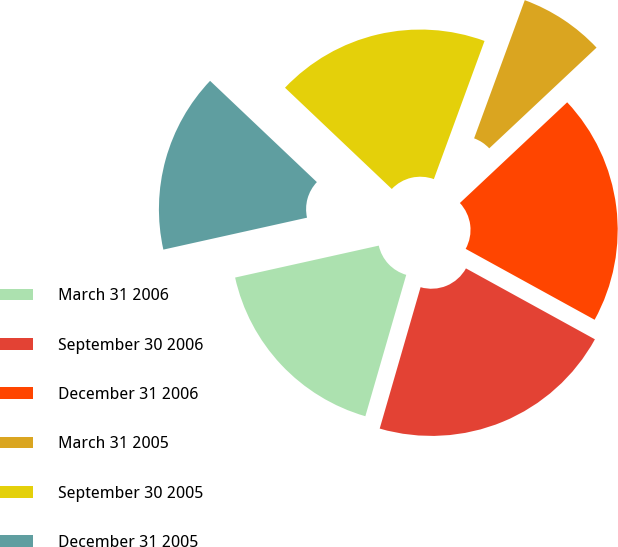<chart> <loc_0><loc_0><loc_500><loc_500><pie_chart><fcel>March 31 2006<fcel>September 30 2006<fcel>December 31 2006<fcel>March 31 2005<fcel>September 30 2005<fcel>December 31 2005<nl><fcel>17.04%<fcel>21.48%<fcel>20.0%<fcel>7.41%<fcel>18.52%<fcel>15.56%<nl></chart> 